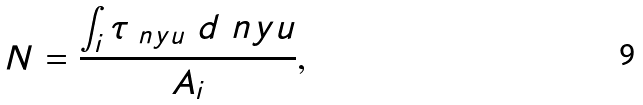<formula> <loc_0><loc_0><loc_500><loc_500>N = \frac { \int _ { i } \tau _ { \ n y u } \ d \ n y u } { A _ { i } } ,</formula> 